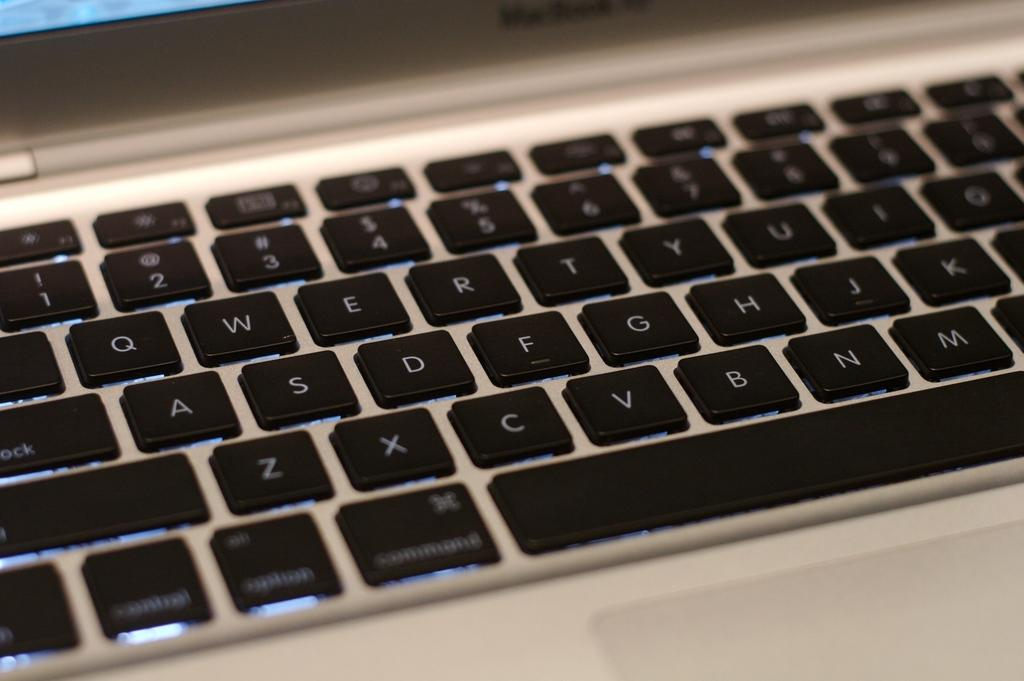<image>
Present a compact description of the photo's key features. A close up of a laptop keyboard with the usual QWERTY keys set up. 